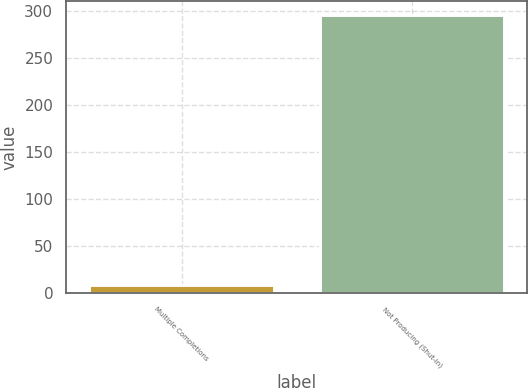<chart> <loc_0><loc_0><loc_500><loc_500><bar_chart><fcel>Multiple Completions<fcel>Not Producing (Shut-in)<nl><fcel>8.1<fcel>295.5<nl></chart> 